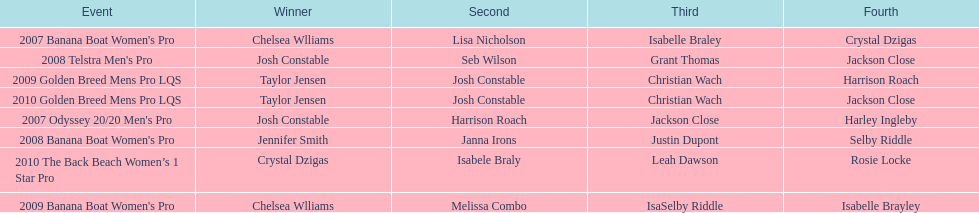Who was the top performer in the 2008 telstra men's pro? Josh Constable. 